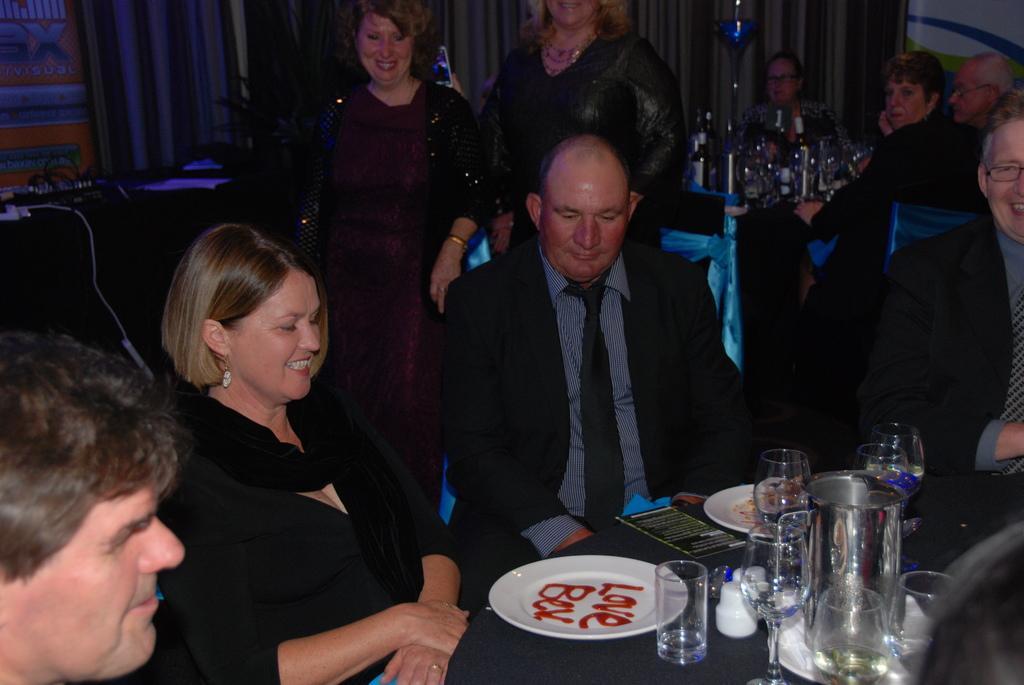Please provide a concise description of this image. The picture is taken inside a room where at the right corner of the picture there is a table, plates and glasses on it and people are sitting in front of the table. One woman is wearing a black dress and behind her there are another two women are standing and behind them there are people sitting on chairs and in front the table there are wine bottles and curtain and plant in the room. 